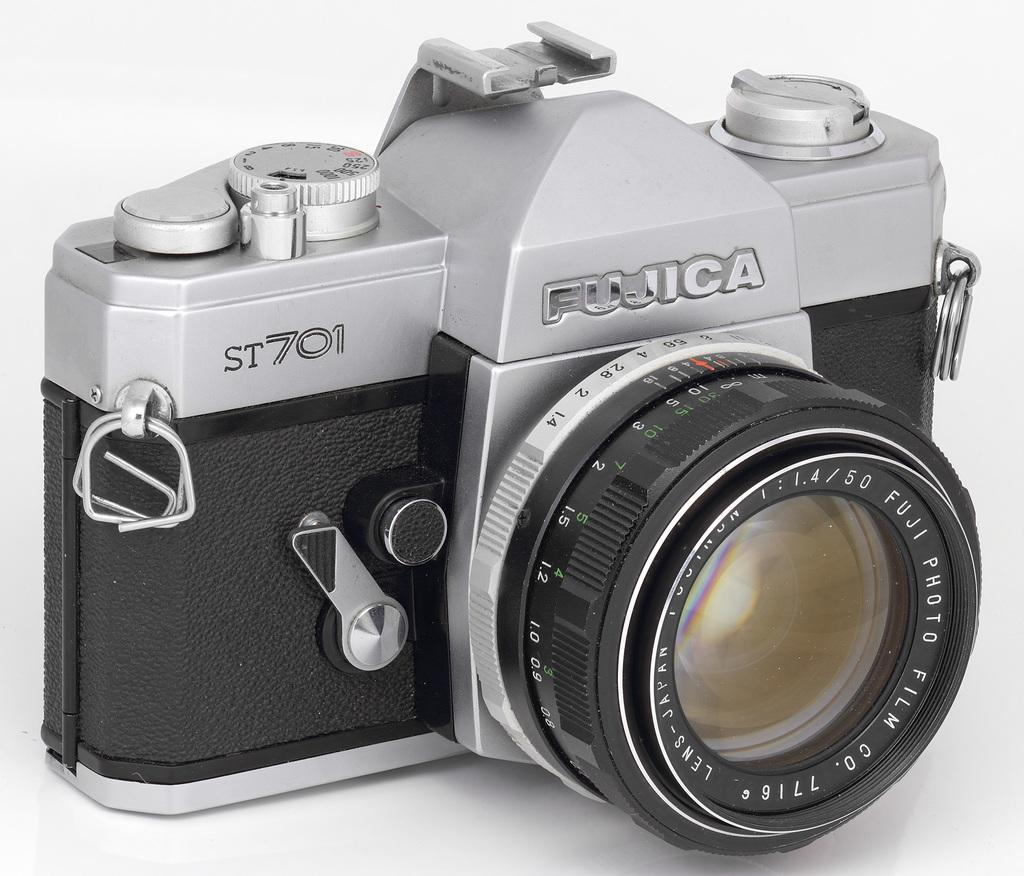<image>
Offer a succinct explanation of the picture presented. A silver and black camera displaying the brand name Fujica. 